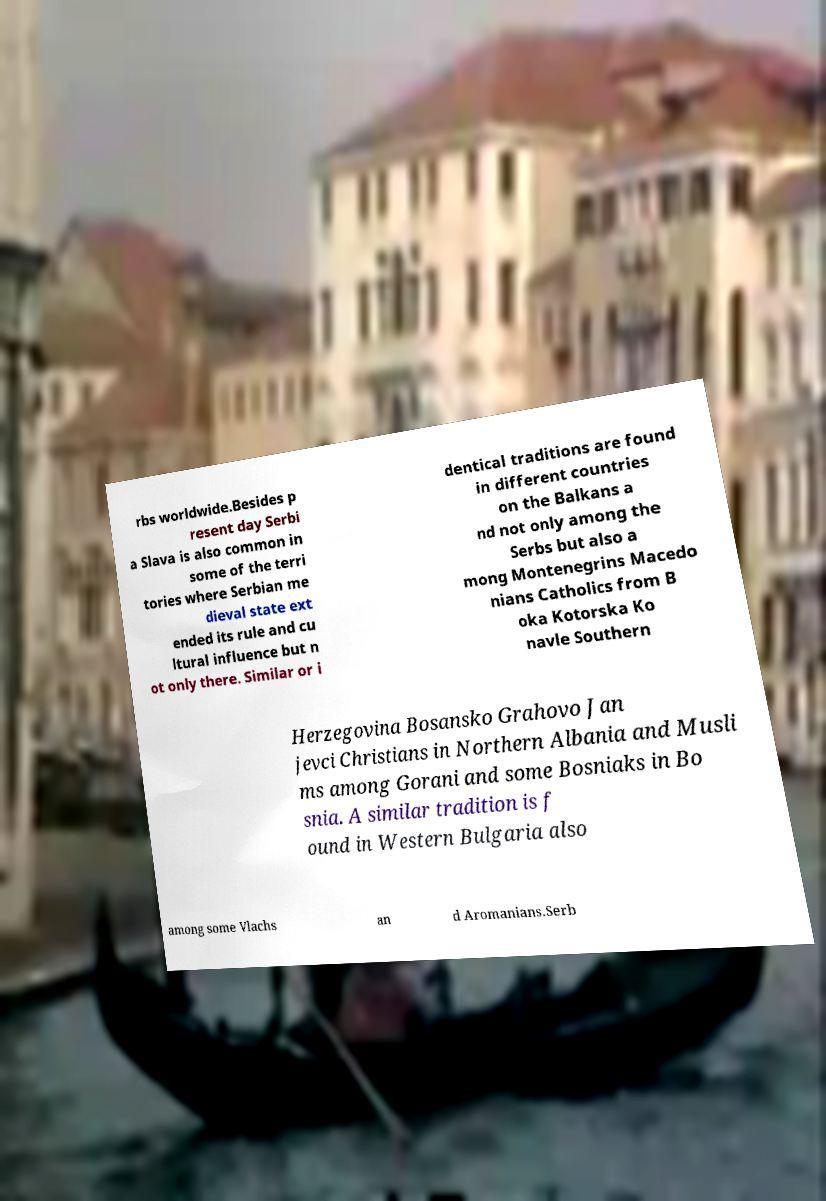Could you extract and type out the text from this image? rbs worldwide.Besides p resent day Serbi a Slava is also common in some of the terri tories where Serbian me dieval state ext ended its rule and cu ltural influence but n ot only there. Similar or i dentical traditions are found in different countries on the Balkans a nd not only among the Serbs but also a mong Montenegrins Macedo nians Catholics from B oka Kotorska Ko navle Southern Herzegovina Bosansko Grahovo Jan jevci Christians in Northern Albania and Musli ms among Gorani and some Bosniaks in Bo snia. A similar tradition is f ound in Western Bulgaria also among some Vlachs an d Aromanians.Serb 